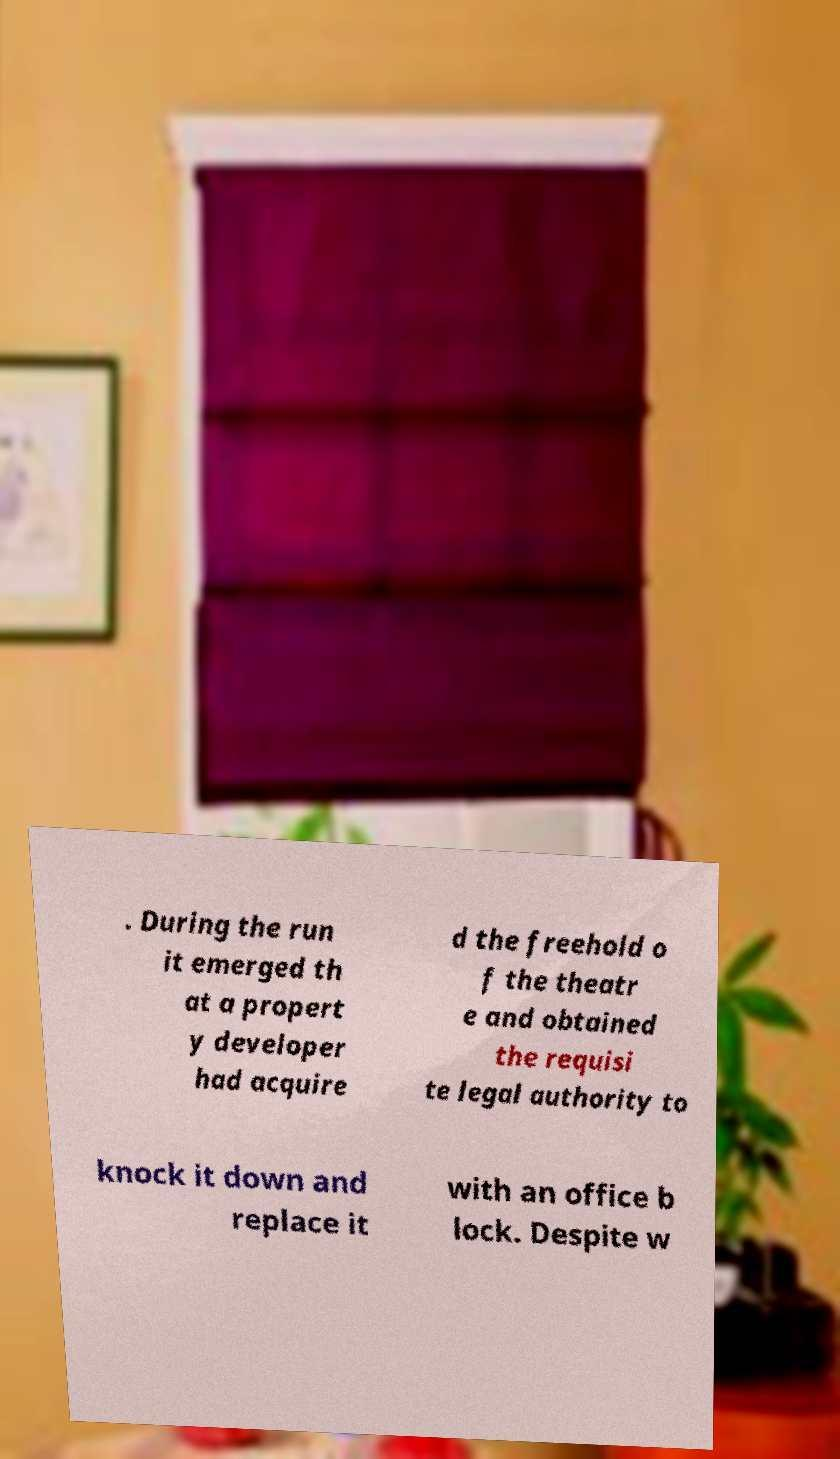Could you assist in decoding the text presented in this image and type it out clearly? . During the run it emerged th at a propert y developer had acquire d the freehold o f the theatr e and obtained the requisi te legal authority to knock it down and replace it with an office b lock. Despite w 